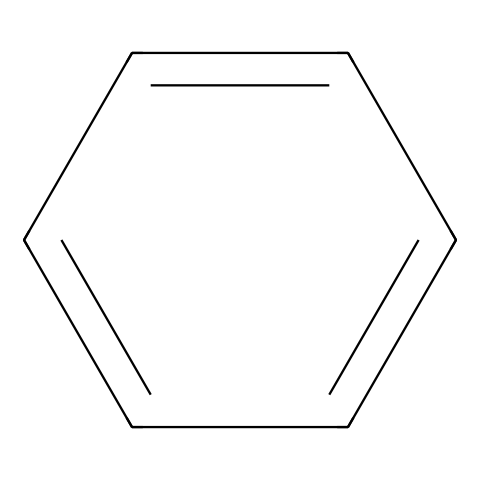What is the name of this chemical? The SMILES representation describes a cyclic compound with alternating double bonds. This specific arrangement corresponds to benzene, a well-known aromatic hydrocarbon.
Answer: benzene How many carbon atoms are in benzene? By interpreting the SMILES notation, c1ccccc1, we see there are six 'c' characters, each representing a carbon atom in a cyclic structure. Therefore, the total number of carbon atoms is six.
Answer: 6 How many hydrogen atoms are bonded to benzene? For benzene, each carbon atom bonds to one hydrogen because it forms a stable aromatic ring with alternating double bonds. Thus, with six carbon atoms, there are six hydrogen atoms connected.
Answer: 6 What type of hydrocarbon is benzene? Benzene is characterized by its rings and delocalized pi electrons, placing it in the category of aromatic hydrocarbons specifically.
Answer: aromatic What is the bond type between carbon atoms in benzene? The alternating double bonds in the structure indicate that the carbon-carbon bonds are of the type known as double bonds and results in resonance stability.
Answer: double bonds How does the molecular structure of benzene affect its stability? The delocalization of electrons over the cyclic structure leads to resonance stabilization. Each carbon atom contributes to the delocalized electron cloud, which makes benzene more stable compared to aliphatic compounds.
Answer: resonance stabilization 